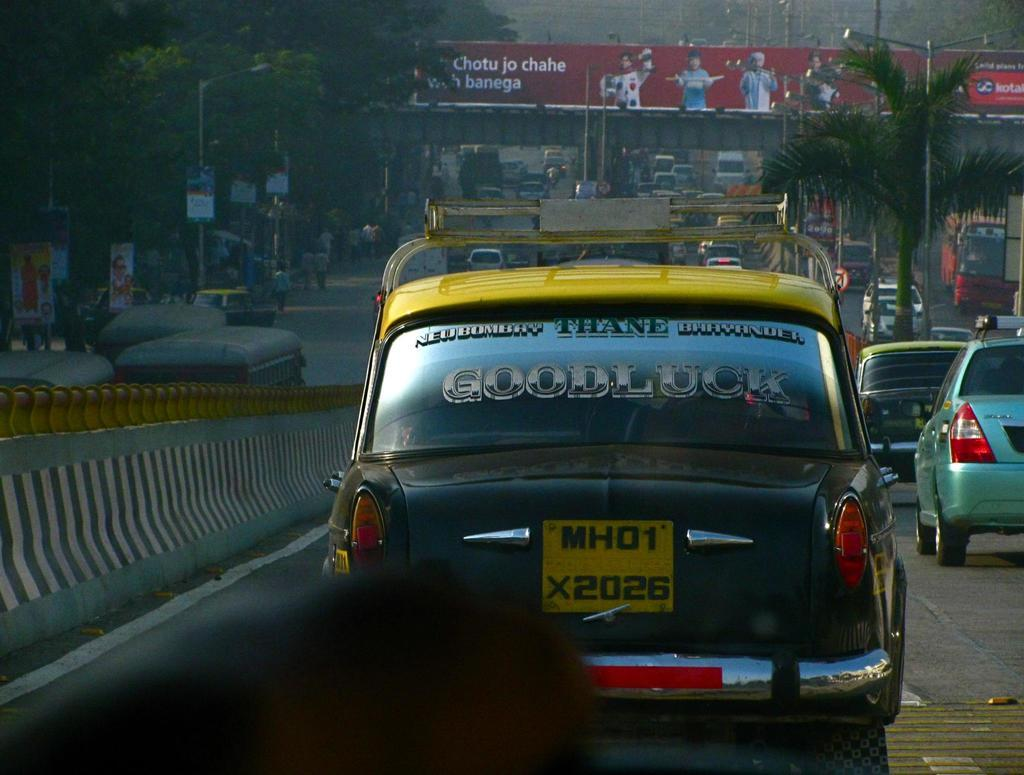<image>
Create a compact narrative representing the image presented. the word goodluck on the back of a car 